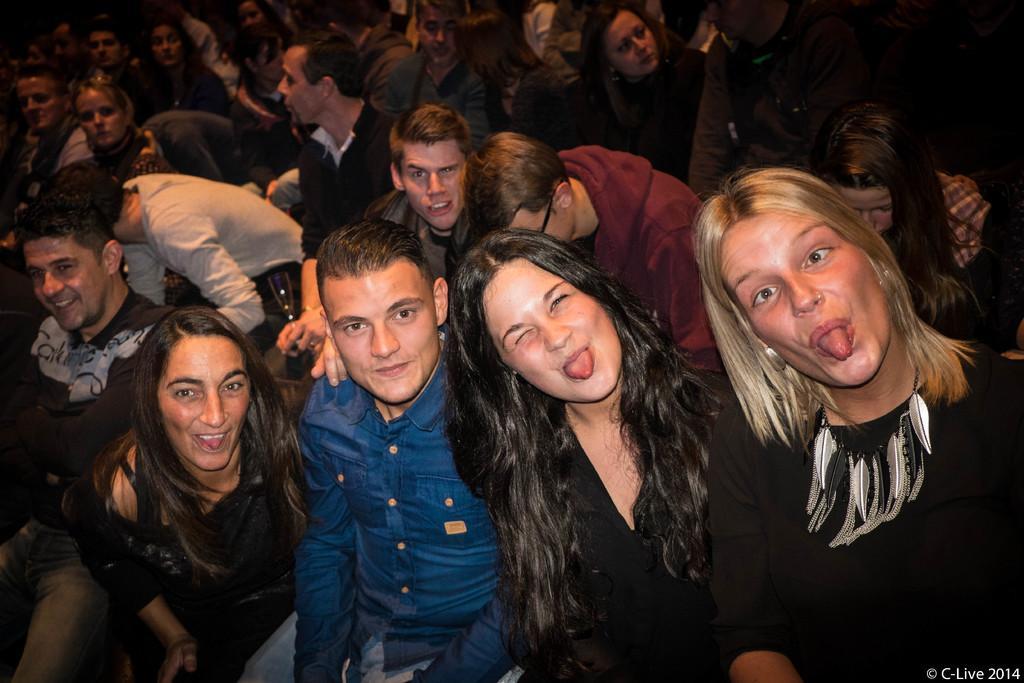Describe this image in one or two sentences. Here we see group of people with a smile on their faces and three women putting their tongue out from their mouth 